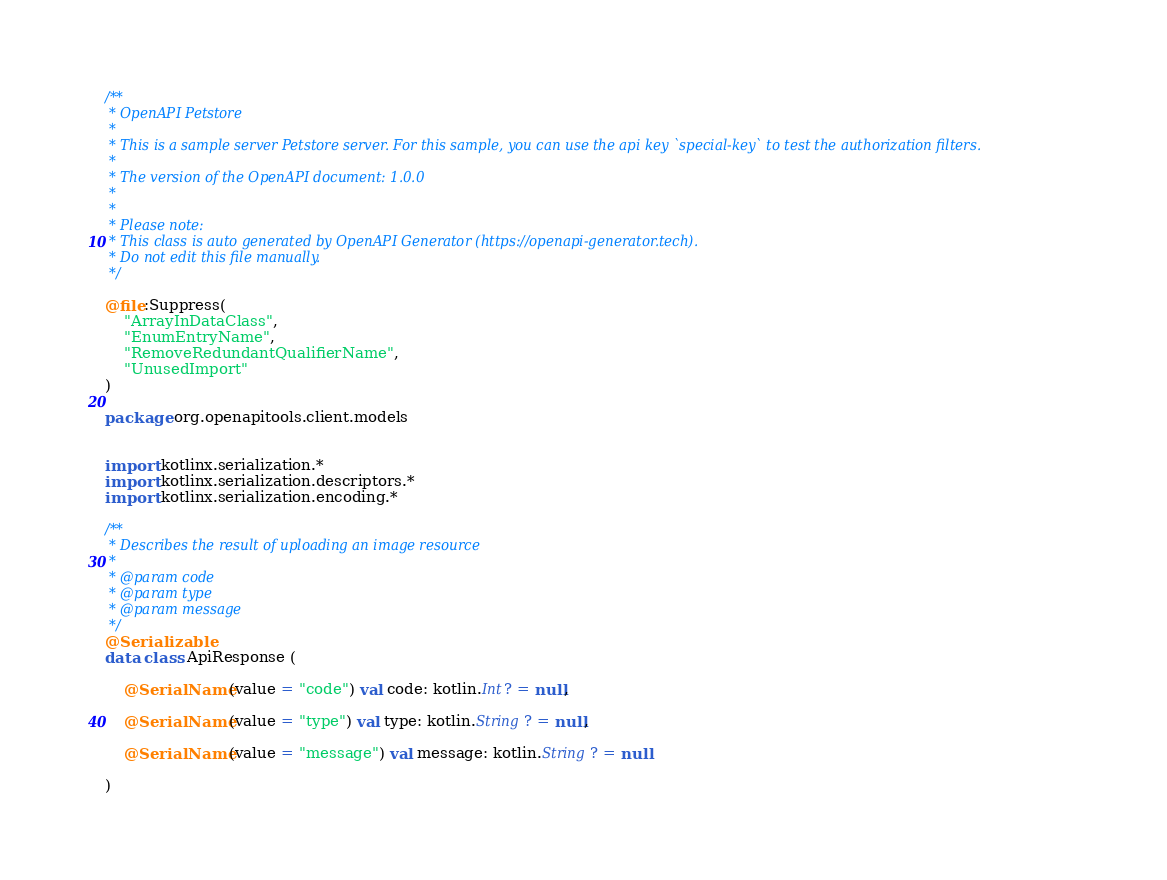Convert code to text. <code><loc_0><loc_0><loc_500><loc_500><_Kotlin_>/**
 * OpenAPI Petstore
 *
 * This is a sample server Petstore server. For this sample, you can use the api key `special-key` to test the authorization filters.
 *
 * The version of the OpenAPI document: 1.0.0
 * 
 *
 * Please note:
 * This class is auto generated by OpenAPI Generator (https://openapi-generator.tech).
 * Do not edit this file manually.
 */

@file:Suppress(
    "ArrayInDataClass",
    "EnumEntryName",
    "RemoveRedundantQualifierName",
    "UnusedImport"
)

package org.openapitools.client.models


import kotlinx.serialization.*
import kotlinx.serialization.descriptors.*
import kotlinx.serialization.encoding.*

/**
 * Describes the result of uploading an image resource
 *
 * @param code 
 * @param type 
 * @param message 
 */
@Serializable
data class ApiResponse (

    @SerialName(value = "code") val code: kotlin.Int? = null,

    @SerialName(value = "type") val type: kotlin.String? = null,

    @SerialName(value = "message") val message: kotlin.String? = null

)

</code> 